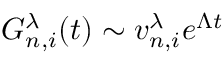Convert formula to latex. <formula><loc_0><loc_0><loc_500><loc_500>G _ { n , i } ^ { \lambda } ( t ) \sim v _ { n , i } ^ { \lambda } e ^ { \Lambda t }</formula> 